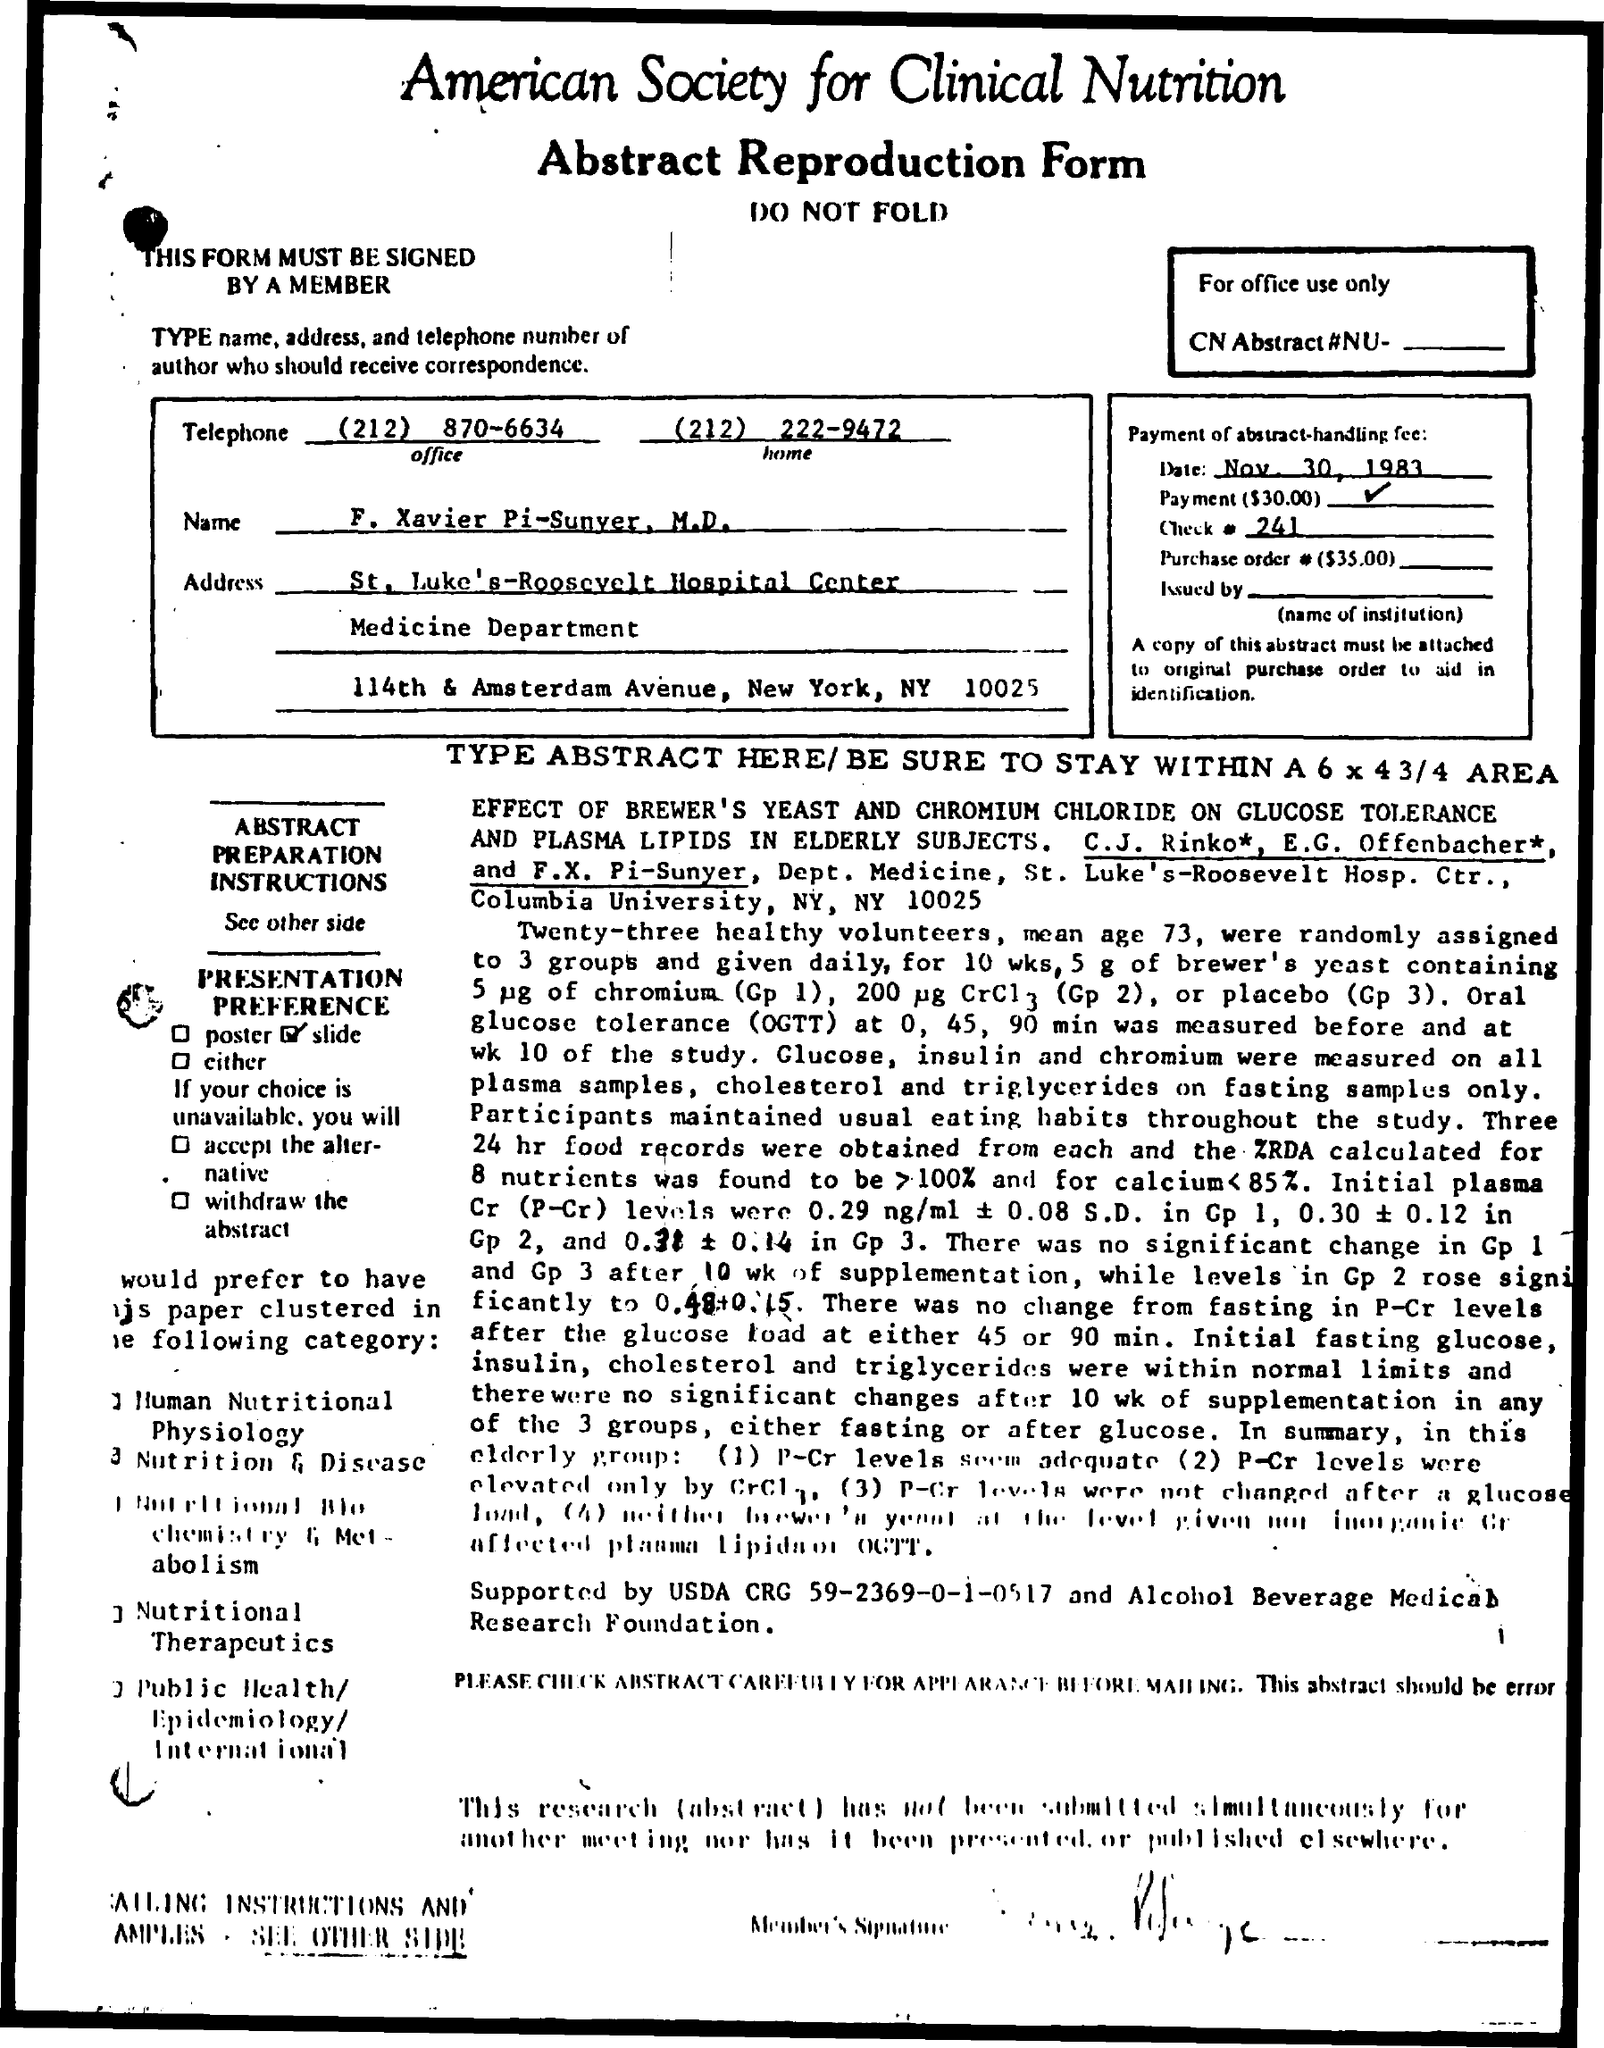What is the office telephone number mentioned ?
Your answer should be very brief. (212) 870-6634. What is the home telephone number ?
Your answer should be very brief. (212) 222-9472. What is the city name mentioned in the address
Your response must be concise. New York. What is the date mentioned ?
Provide a succinct answer. Nov 30, 1983. What is the check # number ?
Ensure brevity in your answer.  241. 